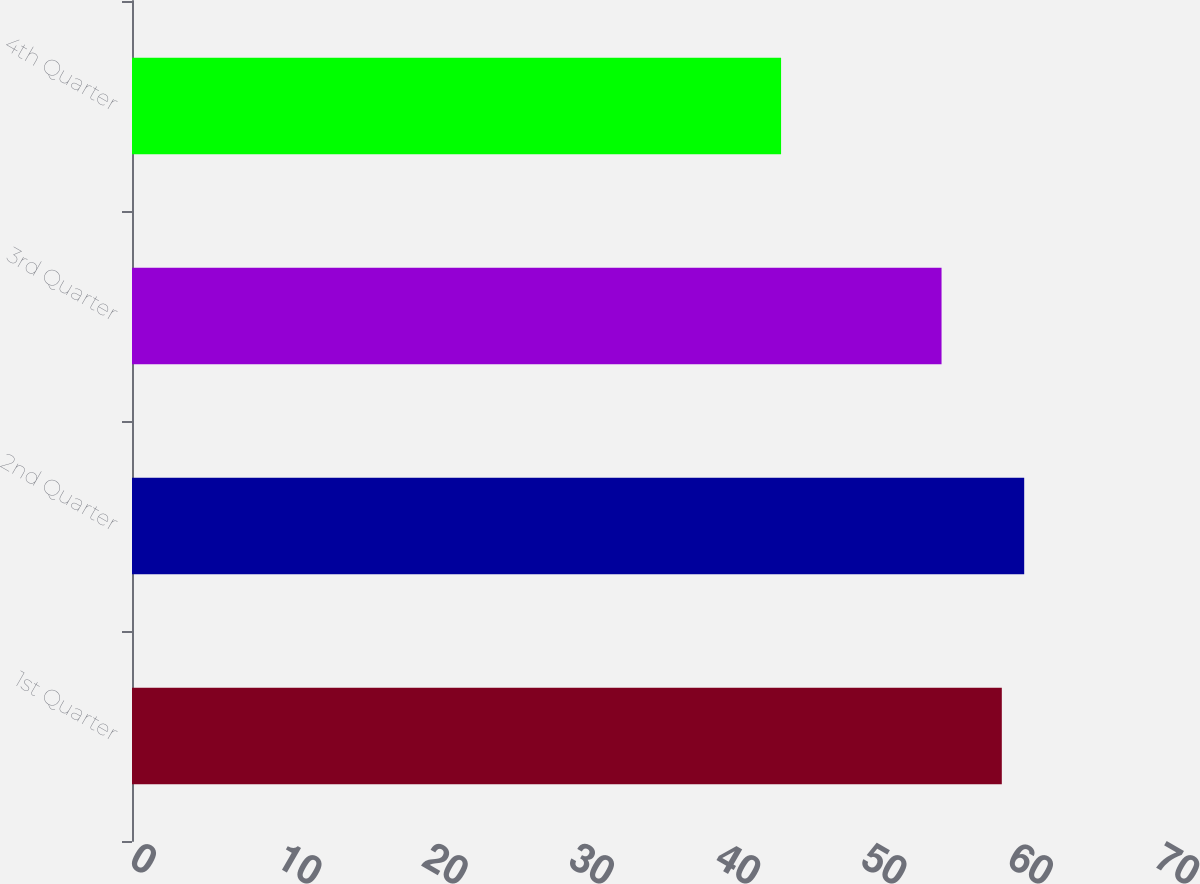Convert chart to OTSL. <chart><loc_0><loc_0><loc_500><loc_500><bar_chart><fcel>1st Quarter<fcel>2nd Quarter<fcel>3rd Quarter<fcel>4th Quarter<nl><fcel>59.46<fcel>60.99<fcel>55.34<fcel>44.37<nl></chart> 